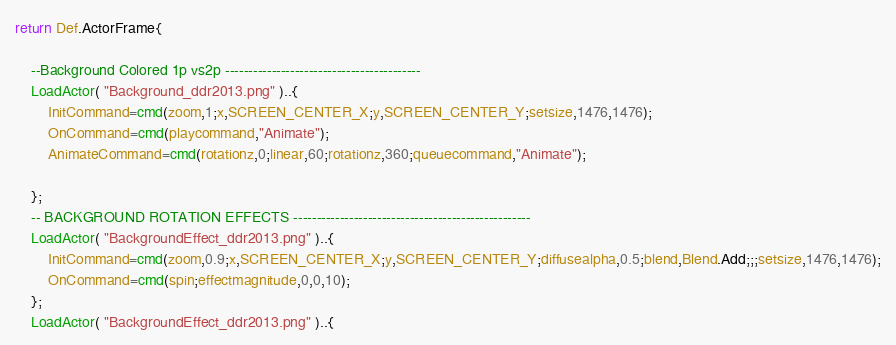<code> <loc_0><loc_0><loc_500><loc_500><_Lua_>return Def.ActorFrame{

	--Background Colored 1p vs2p ------------------------------------------
	LoadActor( "Background_ddr2013.png" )..{
		InitCommand=cmd(zoom,1;x,SCREEN_CENTER_X;y,SCREEN_CENTER_Y;setsize,1476,1476);
		OnCommand=cmd(playcommand,"Animate");
		AnimateCommand=cmd(rotationz,0;linear,60;rotationz,360;queuecommand,"Animate");

	};
	-- BACKGROUND ROTATION EFFECTS ---------------------------------------------------
	LoadActor( "BackgroundEffect_ddr2013.png" )..{
		InitCommand=cmd(zoom,0.9;x,SCREEN_CENTER_X;y,SCREEN_CENTER_Y;diffusealpha,0.5;blend,Blend.Add;;;setsize,1476,1476);
		OnCommand=cmd(spin;effectmagnitude,0,0,10);
	};
	LoadActor( "BackgroundEffect_ddr2013.png" )..{</code> 